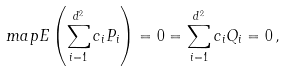<formula> <loc_0><loc_0><loc_500><loc_500>\ m a p E \left ( \sum _ { i = 1 } ^ { d ^ { 2 } } c _ { i } P _ { i } \right ) = 0 = \sum _ { i = 1 } ^ { d ^ { 2 } } c _ { i } Q _ { i } = 0 \, ,</formula> 